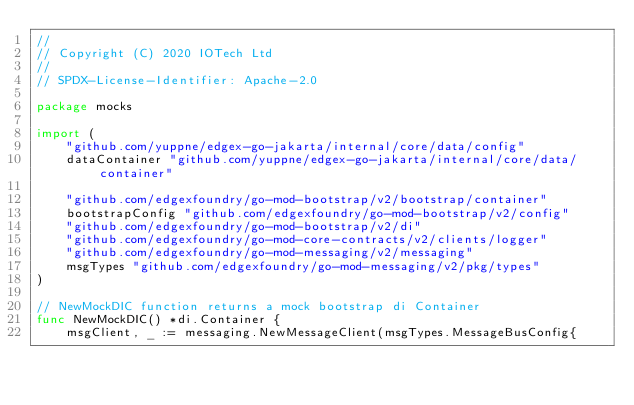<code> <loc_0><loc_0><loc_500><loc_500><_Go_>//
// Copyright (C) 2020 IOTech Ltd
//
// SPDX-License-Identifier: Apache-2.0

package mocks

import (
	"github.com/yuppne/edgex-go-jakarta/internal/core/data/config"
	dataContainer "github.com/yuppne/edgex-go-jakarta/internal/core/data/container"

	"github.com/edgexfoundry/go-mod-bootstrap/v2/bootstrap/container"
	bootstrapConfig "github.com/edgexfoundry/go-mod-bootstrap/v2/config"
	"github.com/edgexfoundry/go-mod-bootstrap/v2/di"
	"github.com/edgexfoundry/go-mod-core-contracts/v2/clients/logger"
	"github.com/edgexfoundry/go-mod-messaging/v2/messaging"
	msgTypes "github.com/edgexfoundry/go-mod-messaging/v2/pkg/types"
)

// NewMockDIC function returns a mock bootstrap di Container
func NewMockDIC() *di.Container {
	msgClient, _ := messaging.NewMessageClient(msgTypes.MessageBusConfig{</code> 